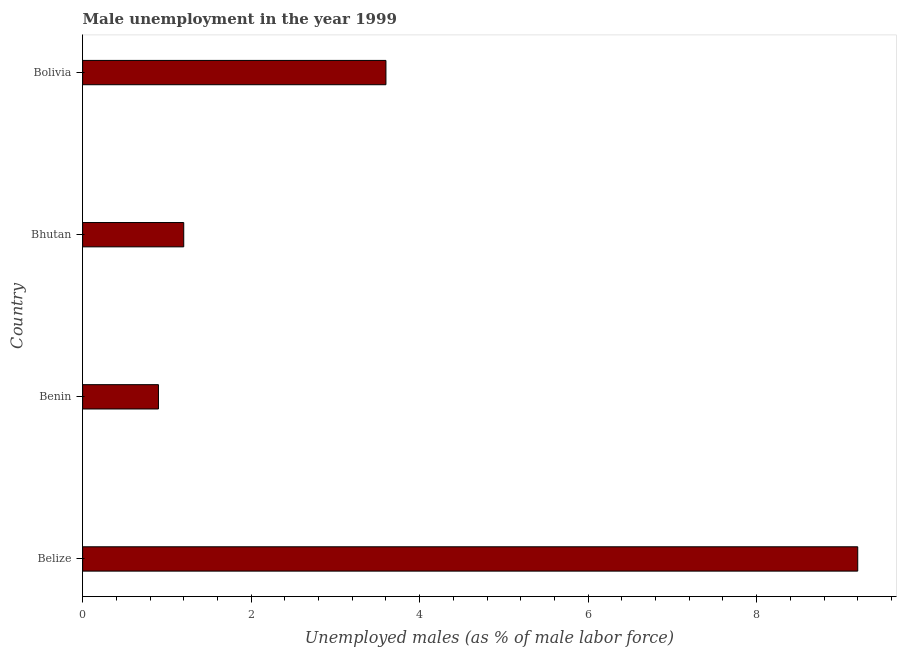Does the graph contain any zero values?
Your response must be concise. No. What is the title of the graph?
Your answer should be very brief. Male unemployment in the year 1999. What is the label or title of the X-axis?
Ensure brevity in your answer.  Unemployed males (as % of male labor force). What is the unemployed males population in Belize?
Your answer should be very brief. 9.2. Across all countries, what is the maximum unemployed males population?
Provide a short and direct response. 9.2. Across all countries, what is the minimum unemployed males population?
Your response must be concise. 0.9. In which country was the unemployed males population maximum?
Your answer should be compact. Belize. In which country was the unemployed males population minimum?
Provide a succinct answer. Benin. What is the sum of the unemployed males population?
Provide a succinct answer. 14.9. What is the average unemployed males population per country?
Give a very brief answer. 3.73. What is the median unemployed males population?
Give a very brief answer. 2.4. In how many countries, is the unemployed males population greater than 2.8 %?
Ensure brevity in your answer.  2. Is the unemployed males population in Bhutan less than that in Bolivia?
Offer a very short reply. Yes. Is the difference between the unemployed males population in Belize and Bolivia greater than the difference between any two countries?
Offer a very short reply. No. What is the difference between the highest and the second highest unemployed males population?
Give a very brief answer. 5.6. Is the sum of the unemployed males population in Benin and Bhutan greater than the maximum unemployed males population across all countries?
Offer a very short reply. No. Are all the bars in the graph horizontal?
Ensure brevity in your answer.  Yes. What is the difference between two consecutive major ticks on the X-axis?
Provide a succinct answer. 2. Are the values on the major ticks of X-axis written in scientific E-notation?
Offer a terse response. No. What is the Unemployed males (as % of male labor force) of Belize?
Your answer should be very brief. 9.2. What is the Unemployed males (as % of male labor force) in Benin?
Your answer should be very brief. 0.9. What is the Unemployed males (as % of male labor force) in Bhutan?
Give a very brief answer. 1.2. What is the Unemployed males (as % of male labor force) in Bolivia?
Provide a short and direct response. 3.6. What is the difference between the Unemployed males (as % of male labor force) in Belize and Benin?
Your answer should be very brief. 8.3. What is the difference between the Unemployed males (as % of male labor force) in Belize and Bolivia?
Provide a succinct answer. 5.6. What is the ratio of the Unemployed males (as % of male labor force) in Belize to that in Benin?
Your answer should be compact. 10.22. What is the ratio of the Unemployed males (as % of male labor force) in Belize to that in Bhutan?
Your response must be concise. 7.67. What is the ratio of the Unemployed males (as % of male labor force) in Belize to that in Bolivia?
Provide a short and direct response. 2.56. What is the ratio of the Unemployed males (as % of male labor force) in Bhutan to that in Bolivia?
Your response must be concise. 0.33. 